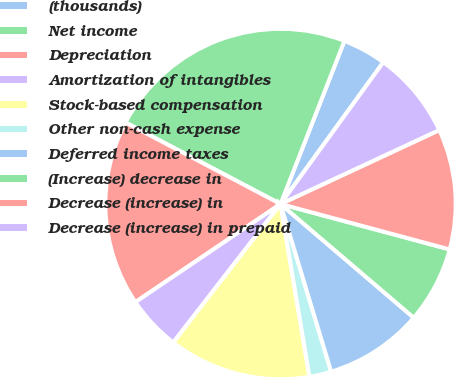Convert chart to OTSL. <chart><loc_0><loc_0><loc_500><loc_500><pie_chart><fcel>(thousands)<fcel>Net income<fcel>Depreciation<fcel>Amortization of intangibles<fcel>Stock-based compensation<fcel>Other non-cash expense<fcel>Deferred income taxes<fcel>(Increase) decrease in<fcel>Decrease (increase) in<fcel>Decrease (increase) in prepaid<nl><fcel>4.04%<fcel>23.23%<fcel>17.17%<fcel>5.05%<fcel>13.13%<fcel>2.02%<fcel>9.09%<fcel>7.07%<fcel>11.11%<fcel>8.08%<nl></chart> 